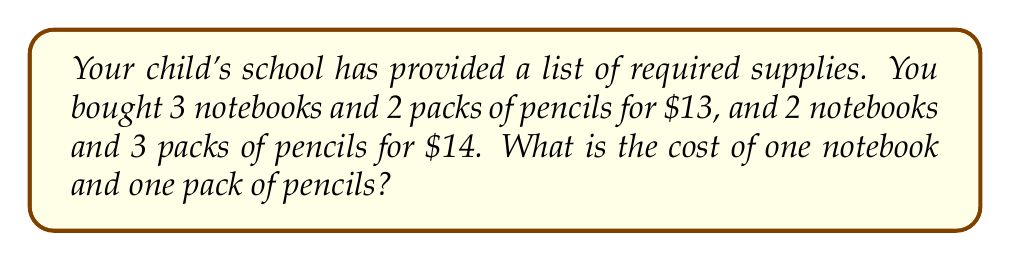What is the answer to this math problem? Let's solve this step-by-step:

1) Let $x$ be the cost of one notebook and $y$ be the cost of one pack of pencils.

2) We can set up two equations based on the given information:
   
   Equation 1: $3x + 2y = 13$
   Equation 2: $2x + 3y = 14$

3) To solve this system of equations, let's use the elimination method:
   
   Multiply equation 1 by 2: $6x + 4y = 26$
   Multiply equation 2 by 3: $6x + 9y = 42$

4) Subtract the first equation from the second:
   
   $5y = 16$

5) Solve for $y$:
   
   $y = \frac{16}{5} = 3.20$

6) Substitute this value of $y$ into equation 1:
   
   $3x + 2(3.20) = 13$
   $3x + 6.40 = 13$
   $3x = 6.60$
   $x = 2.20$

Therefore, one notebook costs $2.20 and one pack of pencils costs $3.20.
Answer: Notebook: $2.20, Pencil pack: $3.20 